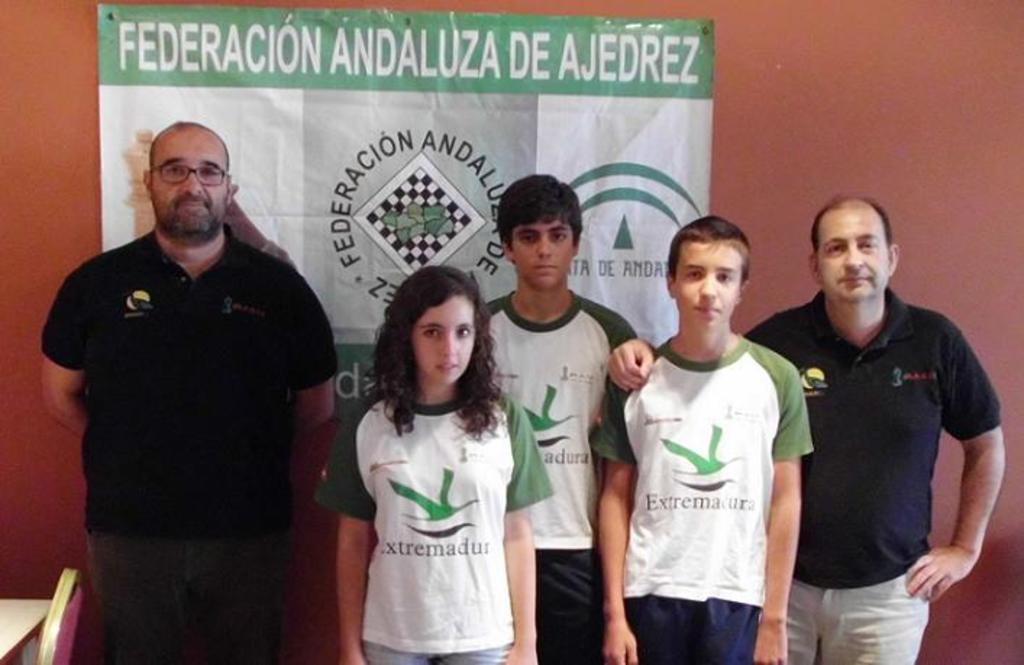Provide a one-sentence caption for the provided image. two men with three kids standing in front of a wall poster saying FEDERACION ANDALUZA DE AJEDREZ. 